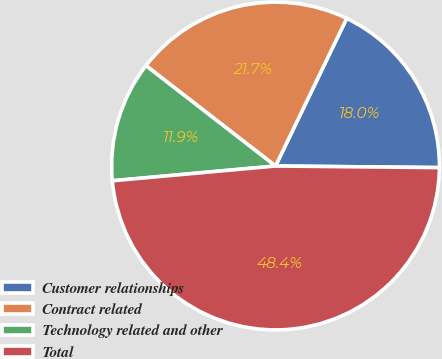Convert chart. <chart><loc_0><loc_0><loc_500><loc_500><pie_chart><fcel>Customer relationships<fcel>Contract related<fcel>Technology related and other<fcel>Total<nl><fcel>18.01%<fcel>21.66%<fcel>11.93%<fcel>48.41%<nl></chart> 